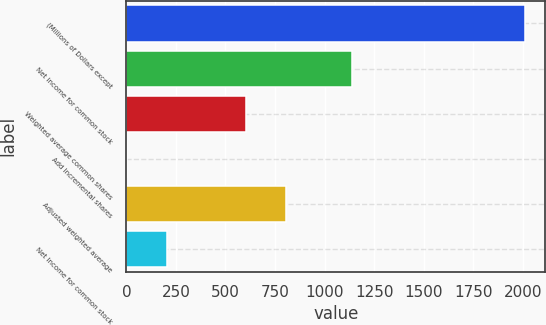Convert chart to OTSL. <chart><loc_0><loc_0><loc_500><loc_500><bar_chart><fcel>(Millions of Dollars except<fcel>Net income for common stock<fcel>Weighted average common shares<fcel>Add Incremental shares<fcel>Adjusted weighted average<fcel>Net Income for common stock<nl><fcel>2012<fcel>1138<fcel>604.72<fcel>1.6<fcel>805.76<fcel>202.64<nl></chart> 